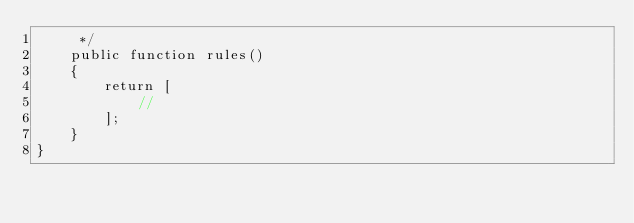<code> <loc_0><loc_0><loc_500><loc_500><_PHP_>     */
    public function rules()
    {
        return [
            //
        ];
    }
}
</code> 